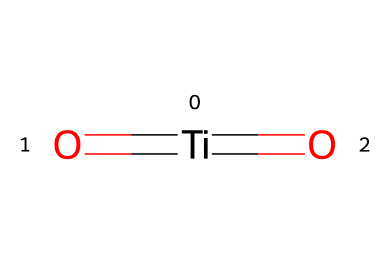How many titanium atoms are present in the structure? The SMILES representation shows one titanium atom, indicated by [Ti].
Answer: one What is the oxidation state of titanium in this compound? The chemical structure shows titanium bonded to two oxygen atoms via double bonds, suggesting it is in a +4 oxidation state, as each oxygen is typically -2.
Answer: +4 What is the molecular formula derived from the SMILES representation? The SMILES indicates one titanium and two oxygen atoms, resulting in the molecular formula TiO2.
Answer: TiO2 What type of chemical bonding is present between titanium and oxygen? The representation shows titanium with double bonds to two oxygen atoms, indicating covalent bonding between them.
Answer: covalent How does titanium dioxide function as a photoreactive chemical? Titanium dioxide absorbs UV light due to its electronic structure, making it effective for applications like sunscreens, where it prevents skin damage.
Answer: absorbs UV light What kind of structure does titanium dioxide have in terms of molecular geometry? The titanium atom is centrally located and bonded to two oxygen atoms in a linear arrangement, indicating a trigonal planar geometry around the titanium.
Answer: trigonal planar What role does titanium dioxide play in sunscreens? Titanium dioxide acts as a physical UV filter, reflecting and scattering UV radiation to protect the skin from sun damage.
Answer: physical UV filter 